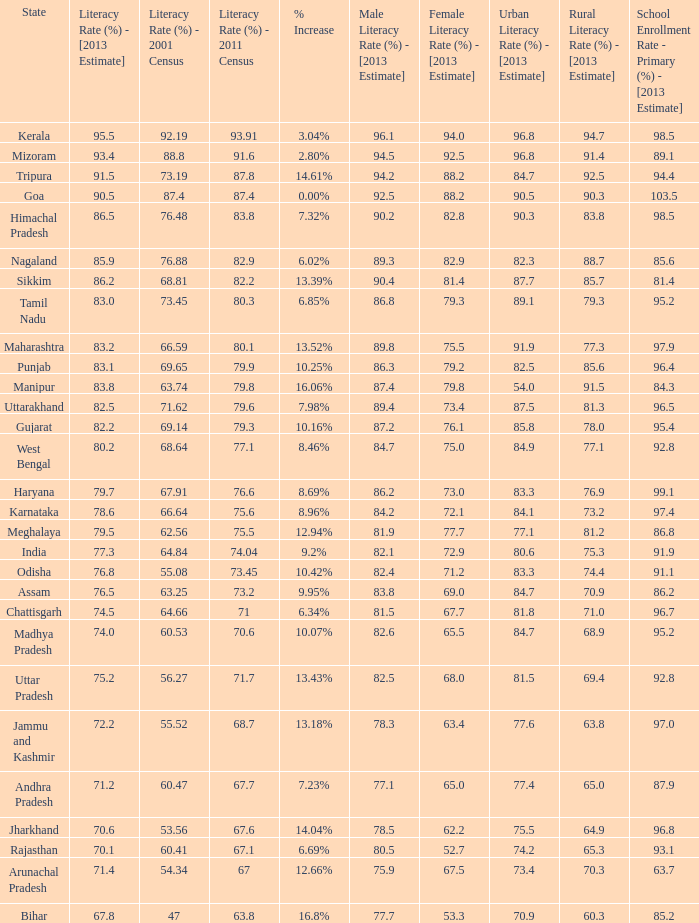What is the average increase in literacy for the states that had a rate higher than 73.2% in 2011, less than 68.81% in 2001, and an estimate of 76.8% for 2013? 10.42%. I'm looking to parse the entire table for insights. Could you assist me with that? {'header': ['State', 'Literacy Rate (%) - [2013 Estimate]', 'Literacy Rate (%) - 2001 Census', 'Literacy Rate (%) - 2011 Census', '% Increase', 'Male Literacy Rate (%) - [2013 Estimate]', 'Female Literacy Rate (%) - [2013 Estimate]', 'Urban Literacy Rate (%) - [2013 Estimate]', 'Rural Literacy Rate (%) - [2013 Estimate]', 'School Enrollment Rate - Primary (%) - [2013 Estimate]'], 'rows': [['Kerala', '95.5', '92.19', '93.91', '3.04%', '96.1', '94.0', '96.8', '94.7', '98.5'], ['Mizoram', '93.4', '88.8', '91.6', '2.80%', '94.5', '92.5', '96.8', '91.4', '89.1'], ['Tripura', '91.5', '73.19', '87.8', '14.61%', '94.2', '88.2', '84.7', '92.5', '94.4'], ['Goa', '90.5', '87.4', '87.4', '0.00%', '92.5', '88.2', '90.5', '90.3', '103.5'], ['Himachal Pradesh', '86.5', '76.48', '83.8', '7.32%', '90.2', '82.8', '90.3', '83.8', '98.5'], ['Nagaland', '85.9', '76.88', '82.9', '6.02%', '89.3', '82.9', '82.3', '88.7', '85.6'], ['Sikkim', '86.2', '68.81', '82.2', '13.39%', '90.4', '81.4', '87.7', '85.7', '81.4'], ['Tamil Nadu', '83.0', '73.45', '80.3', '6.85%', '86.8', '79.3', '89.1', '79.3', '95.2'], ['Maharashtra', '83.2', '66.59', '80.1', '13.52%', '89.8', '75.5', '91.9', '77.3', '97.9'], ['Punjab', '83.1', '69.65', '79.9', '10.25%', '86.3', '79.2', '82.5', '85.6', '96.4'], ['Manipur', '83.8', '63.74', '79.8', '16.06%', '87.4', '79.8', '54.0', '91.5', '84.3'], ['Uttarakhand', '82.5', '71.62', '79.6', '7.98%', '89.4', '73.4', '87.5', '81.3', '96.5'], ['Gujarat', '82.2', '69.14', '79.3', '10.16%', '87.2', '76.1', '85.8', '78.0', '95.4'], ['West Bengal', '80.2', '68.64', '77.1', '8.46%', '84.7', '75.0', '84.9', '77.1', '92.8'], ['Haryana', '79.7', '67.91', '76.6', '8.69%', '86.2', '73.0', '83.3', '76.9', '99.1'], ['Karnataka', '78.6', '66.64', '75.6', '8.96%', '84.2', '72.1', '84.1', '73.2', '97.4'], ['Meghalaya', '79.5', '62.56', '75.5', '12.94%', '81.9', '77.7', '77.1', '81.2', '86.8'], ['India', '77.3', '64.84', '74.04', '9.2%', '82.1', '72.9', '80.6', '75.3', '91.9'], ['Odisha', '76.8', '55.08', '73.45', '10.42%', '82.4', '71.2', '83.3', '74.4', '91.1'], ['Assam', '76.5', '63.25', '73.2', '9.95%', '83.8', '69.0', '84.7', '70.9', '86.2'], ['Chattisgarh', '74.5', '64.66', '71', '6.34%', '81.5', '67.7', '81.8', '71.0', '96.7'], ['Madhya Pradesh', '74.0', '60.53', '70.6', '10.07%', '82.6', '65.5', '84.7', '68.9', '95.2'], ['Uttar Pradesh', '75.2', '56.27', '71.7', '13.43%', '82.5', '68.0', '81.5', '69.4', '92.8'], ['Jammu and Kashmir', '72.2', '55.52', '68.7', '13.18%', '78.3', '63.4', '77.6', '63.8', '97.0'], ['Andhra Pradesh', '71.2', '60.47', '67.7', '7.23%', '77.1', '65.0', '77.4', '65.0', '87.9'], ['Jharkhand', '70.6', '53.56', '67.6', '14.04%', '78.5', '62.2', '75.5', '64.9', '96.8'], ['Rajasthan', '70.1', '60.41', '67.1', '6.69%', '80.5', '52.7', '74.2', '65.3', '93.1'], ['Arunachal Pradesh', '71.4', '54.34', '67', '12.66%', '75.9', '67.5', '73.4', '70.3', '63.7'], ['Bihar', '67.8', '47', '63.8', '16.8%', '77.7', '53.3', '70.9', '60.3', '85.2']]} 